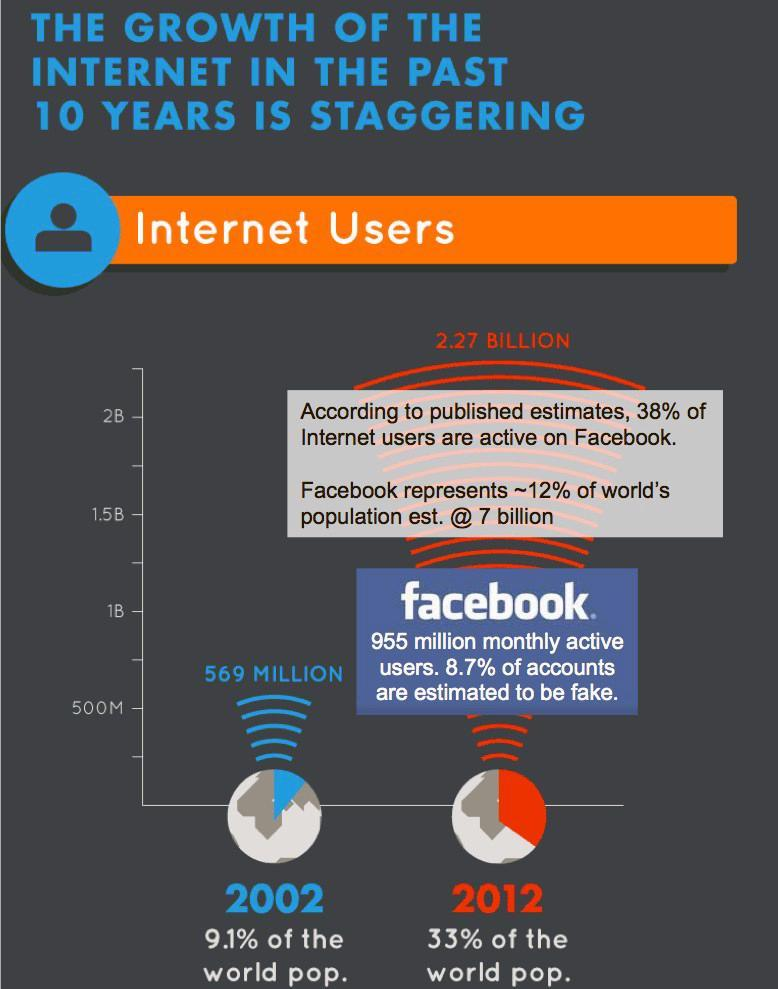What is the number of facebook users in 2002?
Answer the question with a short phrase. 569 MILLION What is the number of facebook users in 2012? 2.27 BILLION 